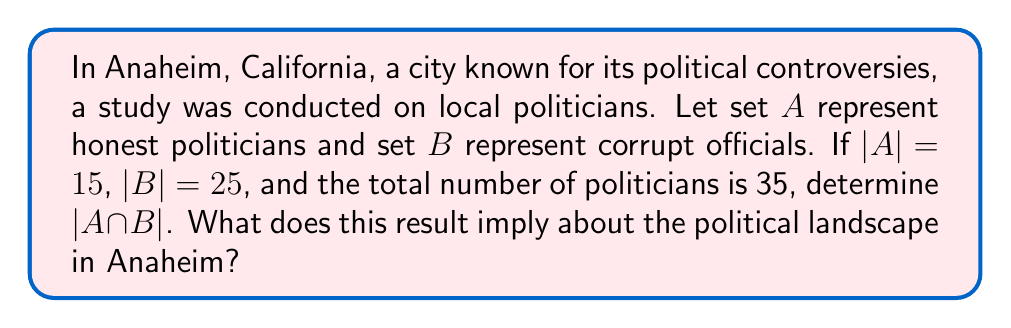Teach me how to tackle this problem. Let's approach this step-by-step using set theory:

1) Let $U$ be the universal set of all politicians in Anaheim. We're given that $|U| = 35$.

2) We know that $|A| = 15$ and $|B| = 25$.

3) To find $|A \cap B|$, we can use the formula:

   $|A \cup B| = |A| + |B| - |A \cap B|$

4) We also know that $|A \cup B| = |U| = 35$, because every politician is either honest or corrupt (or both).

5) Substituting the known values:

   $35 = 15 + 25 - |A \cap B|$

6) Solving for $|A \cap B|$:

   $|A \cap B| = 15 + 25 - 35 = 5$

This result implies that there are 5 politicians in Anaheim who are classified as both "honest" and "corrupt". This paradoxical outcome suggests a deeply troubling political landscape where the line between integrity and corruption is blurred, potentially fueling resident anger and disappointment in the city's governance.
Answer: $|A \cap B| = 5$ 